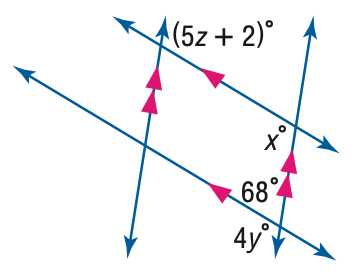Answer the mathemtical geometry problem and directly provide the correct option letter.
Question: Find z in the figure.
Choices: A: 22 B: 24 C: 26 D: 28 A 